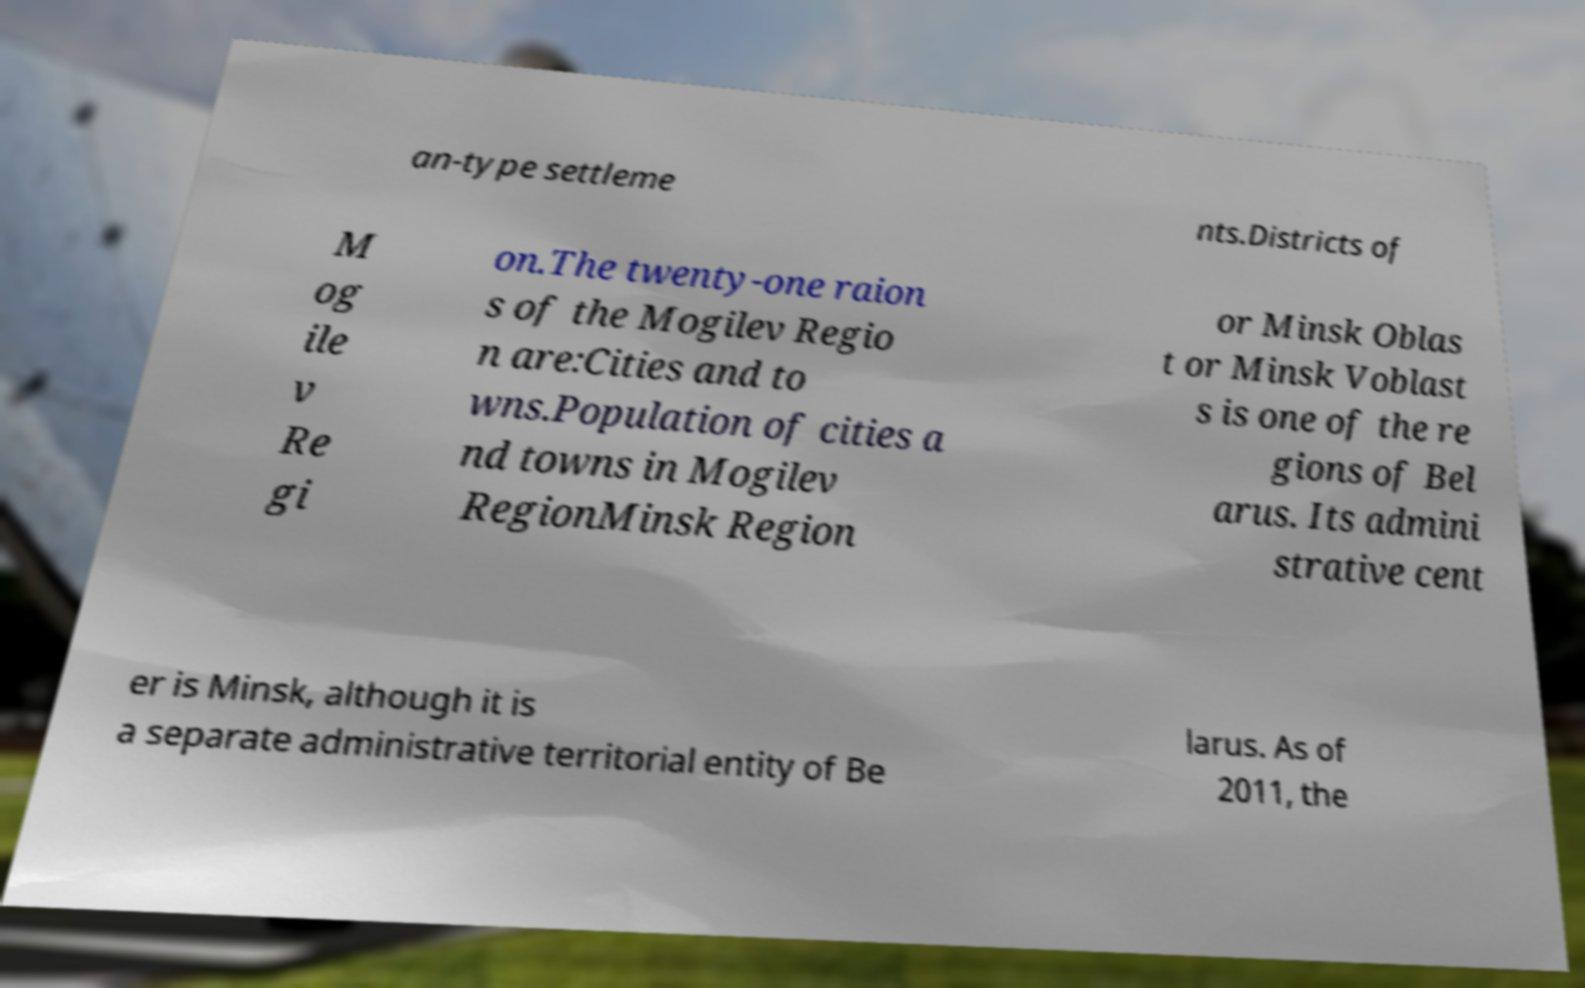Please read and relay the text visible in this image. What does it say? an-type settleme nts.Districts of M og ile v Re gi on.The twenty-one raion s of the Mogilev Regio n are:Cities and to wns.Population of cities a nd towns in Mogilev RegionMinsk Region or Minsk Oblas t or Minsk Voblast s is one of the re gions of Bel arus. Its admini strative cent er is Minsk, although it is a separate administrative territorial entity of Be larus. As of 2011, the 